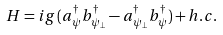<formula> <loc_0><loc_0><loc_500><loc_500>H = i g \, ( a _ { \psi } ^ { \dagger } b _ { \psi _ { \perp } } ^ { \dagger } - a _ { \psi _ { \perp } } ^ { \dagger } b _ { \psi } ^ { \dagger } ) + h . c .</formula> 